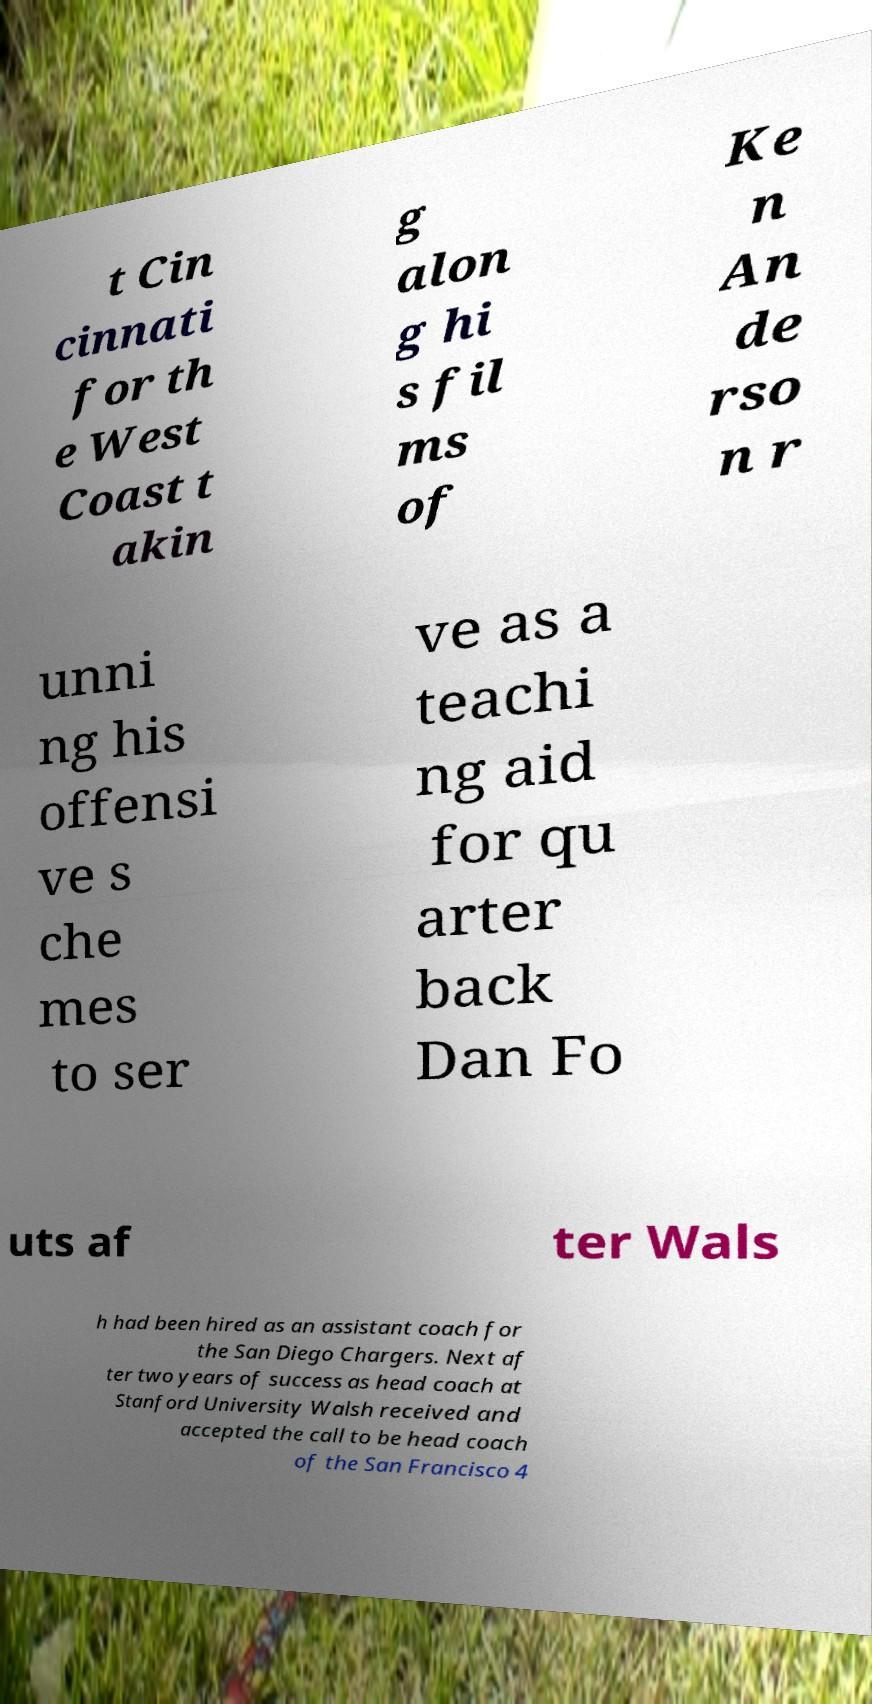Could you extract and type out the text from this image? t Cin cinnati for th e West Coast t akin g alon g hi s fil ms of Ke n An de rso n r unni ng his offensi ve s che mes to ser ve as a teachi ng aid for qu arter back Dan Fo uts af ter Wals h had been hired as an assistant coach for the San Diego Chargers. Next af ter two years of success as head coach at Stanford University Walsh received and accepted the call to be head coach of the San Francisco 4 